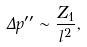Convert formula to latex. <formula><loc_0><loc_0><loc_500><loc_500>\Delta p ^ { \prime \prime } \sim \frac { Z _ { 1 } } { l ^ { 2 } } ,</formula> 